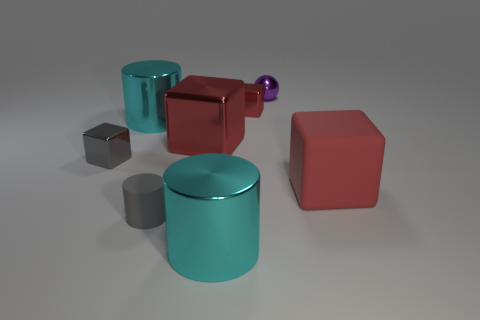How many big objects are either red cylinders or gray blocks?
Ensure brevity in your answer.  0. Are there any other things that are the same shape as the purple shiny thing?
Offer a terse response. No. What color is the small sphere that is the same material as the small gray cube?
Offer a terse response. Purple. The shiny cylinder in front of the tiny gray block is what color?
Offer a very short reply. Cyan. What number of big metal blocks have the same color as the big rubber cube?
Give a very brief answer. 1. Are there fewer red cubes that are on the left side of the matte cube than things that are on the right side of the gray shiny thing?
Provide a short and direct response. Yes. What number of balls are left of the small cylinder?
Make the answer very short. 0. Is there a cylinder that has the same material as the purple ball?
Provide a short and direct response. Yes. Are there more tiny shiny objects that are behind the tiny gray metal cube than large red shiny things that are left of the small purple metallic sphere?
Offer a terse response. Yes. The rubber block is what size?
Make the answer very short. Large. 